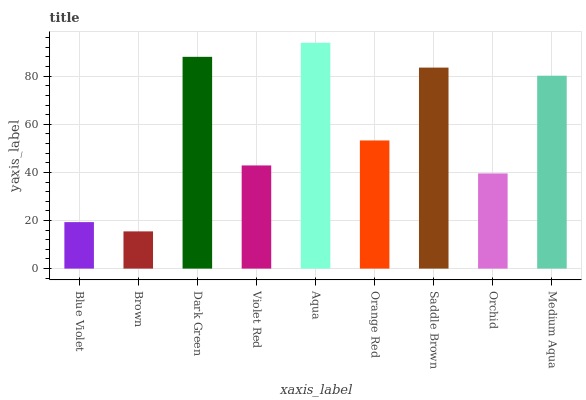Is Brown the minimum?
Answer yes or no. Yes. Is Aqua the maximum?
Answer yes or no. Yes. Is Dark Green the minimum?
Answer yes or no. No. Is Dark Green the maximum?
Answer yes or no. No. Is Dark Green greater than Brown?
Answer yes or no. Yes. Is Brown less than Dark Green?
Answer yes or no. Yes. Is Brown greater than Dark Green?
Answer yes or no. No. Is Dark Green less than Brown?
Answer yes or no. No. Is Orange Red the high median?
Answer yes or no. Yes. Is Orange Red the low median?
Answer yes or no. Yes. Is Violet Red the high median?
Answer yes or no. No. Is Dark Green the low median?
Answer yes or no. No. 